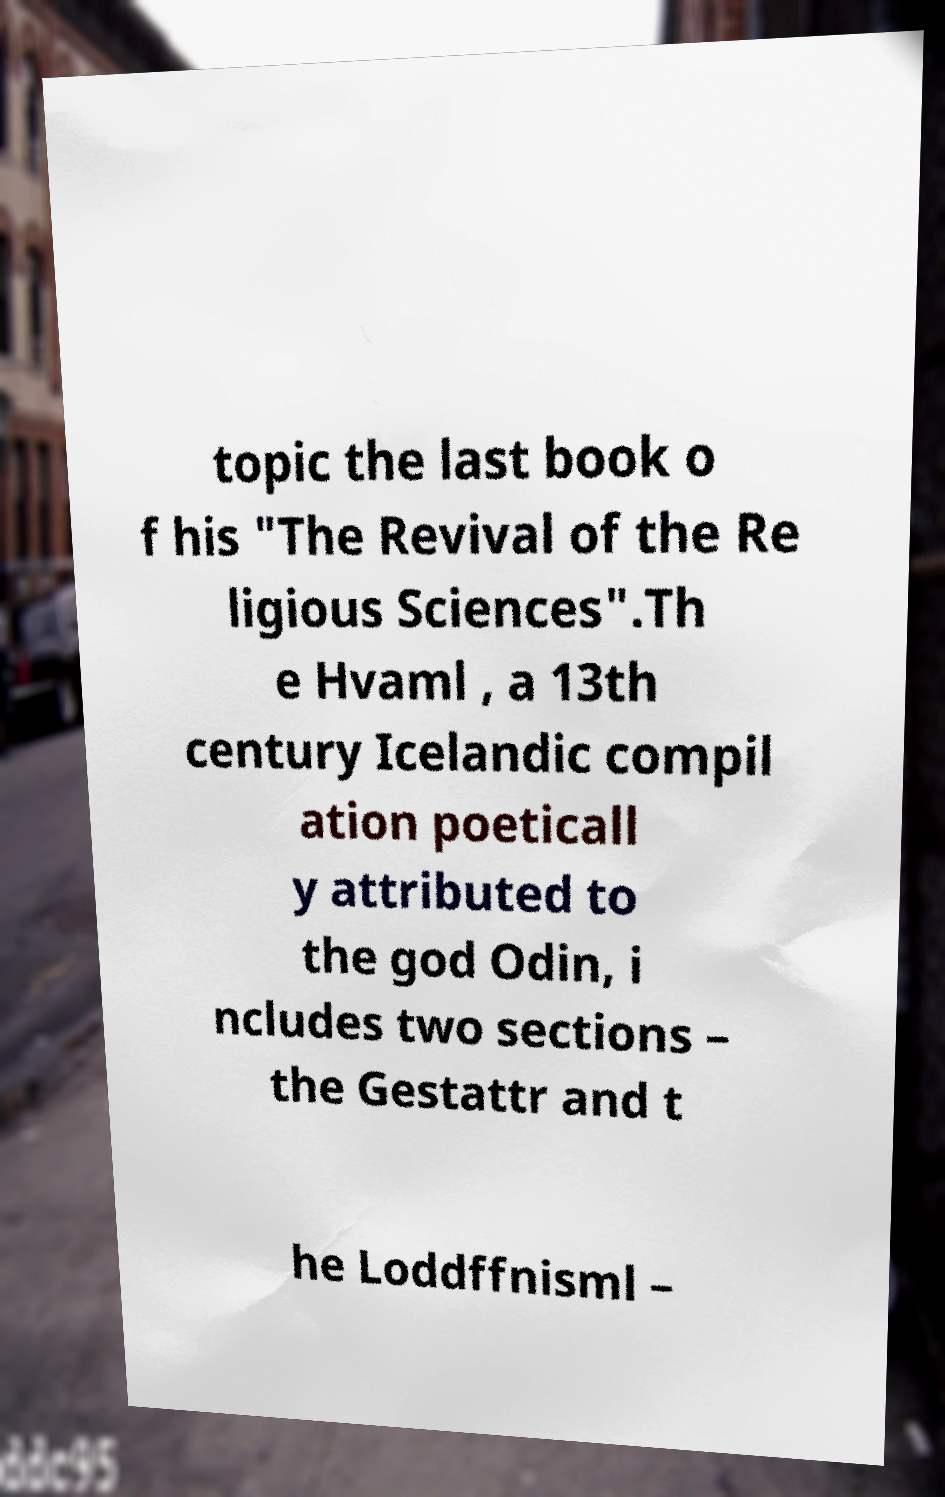Could you assist in decoding the text presented in this image and type it out clearly? topic the last book o f his "The Revival of the Re ligious Sciences".Th e Hvaml , a 13th century Icelandic compil ation poeticall y attributed to the god Odin, i ncludes two sections – the Gestattr and t he Loddffnisml – 